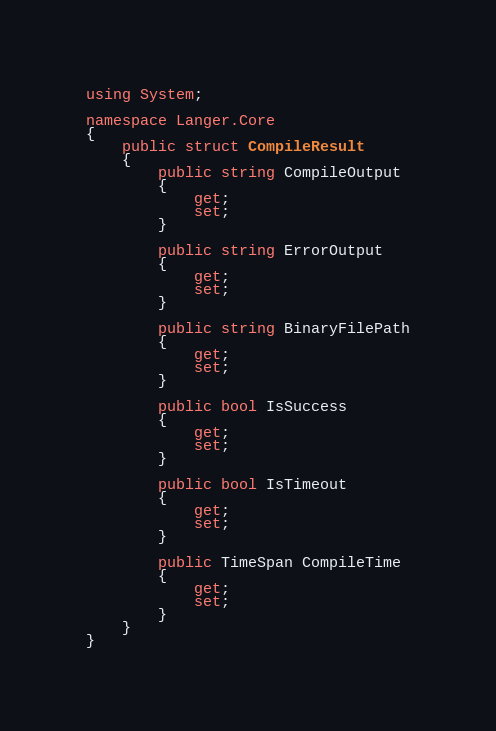Convert code to text. <code><loc_0><loc_0><loc_500><loc_500><_C#_>using System;

namespace Langer.Core
{
    public struct CompileResult
    {
        public string CompileOutput
        {
            get;
            set;
        }

        public string ErrorOutput
        {
            get;
            set;
        }

        public string BinaryFilePath
        {
            get;
            set;
        }

        public bool IsSuccess
        {
            get;
            set;
        }

        public bool IsTimeout
        {
            get;
            set;
        }

        public TimeSpan CompileTime
        {
            get;
            set;
        }
    }
}</code> 